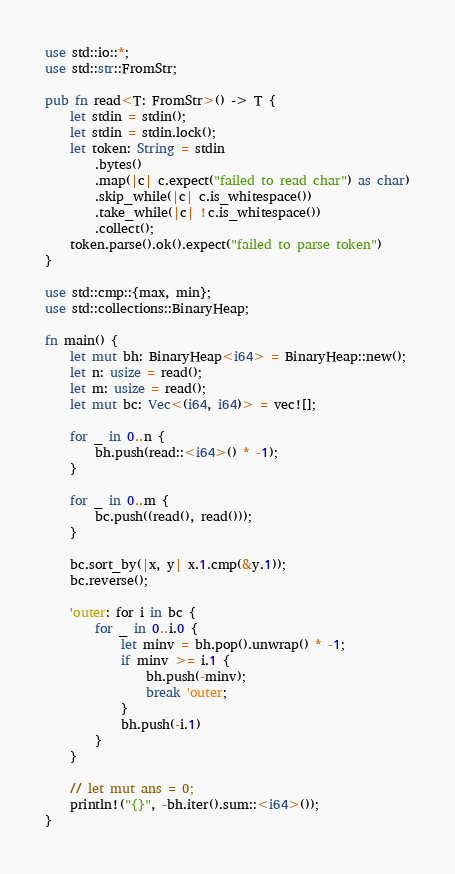<code> <loc_0><loc_0><loc_500><loc_500><_Rust_>use std::io::*;
use std::str::FromStr;

pub fn read<T: FromStr>() -> T {
    let stdin = stdin();
    let stdin = stdin.lock();
    let token: String = stdin
        .bytes()
        .map(|c| c.expect("failed to read char") as char)
        .skip_while(|c| c.is_whitespace())
        .take_while(|c| !c.is_whitespace())
        .collect();
    token.parse().ok().expect("failed to parse token")
}

use std::cmp::{max, min};
use std::collections::BinaryHeap;

fn main() {
    let mut bh: BinaryHeap<i64> = BinaryHeap::new();
    let n: usize = read();
    let m: usize = read();
    let mut bc: Vec<(i64, i64)> = vec![];

    for _ in 0..n {
        bh.push(read::<i64>() * -1);
    }

    for _ in 0..m {
        bc.push((read(), read()));
    }

    bc.sort_by(|x, y| x.1.cmp(&y.1));
    bc.reverse();

    'outer: for i in bc {
        for _ in 0..i.0 {
            let minv = bh.pop().unwrap() * -1;
            if minv >= i.1 {
                bh.push(-minv);
                break 'outer;
            }
            bh.push(-i.1)
        }
    }

    // let mut ans = 0;
    println!("{}", -bh.iter().sum::<i64>());
}
</code> 